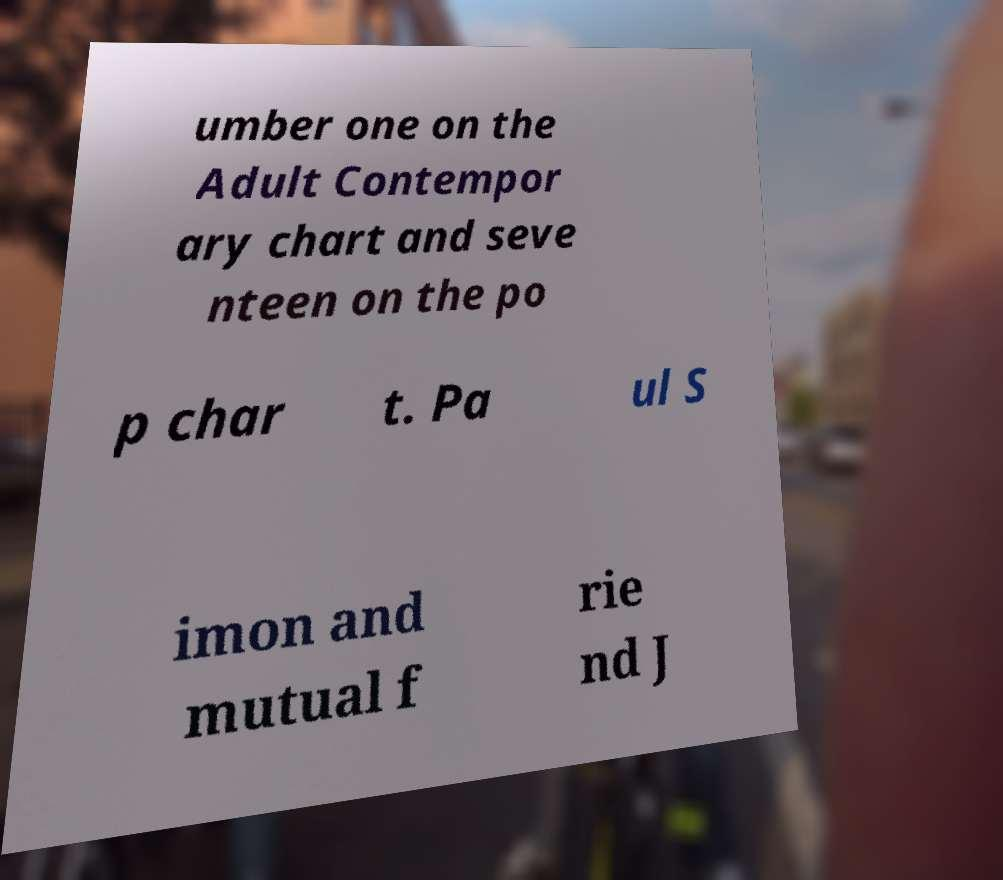What messages or text are displayed in this image? I need them in a readable, typed format. umber one on the Adult Contempor ary chart and seve nteen on the po p char t. Pa ul S imon and mutual f rie nd J 